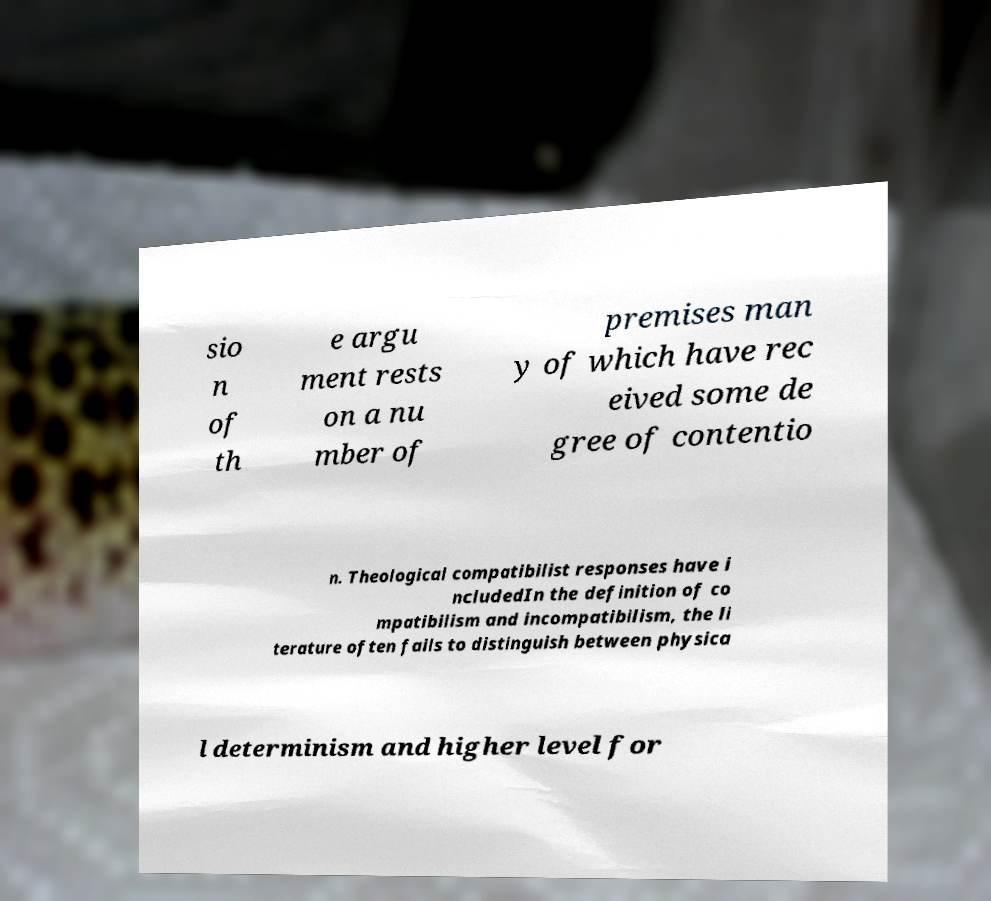There's text embedded in this image that I need extracted. Can you transcribe it verbatim? sio n of th e argu ment rests on a nu mber of premises man y of which have rec eived some de gree of contentio n. Theological compatibilist responses have i ncludedIn the definition of co mpatibilism and incompatibilism, the li terature often fails to distinguish between physica l determinism and higher level for 